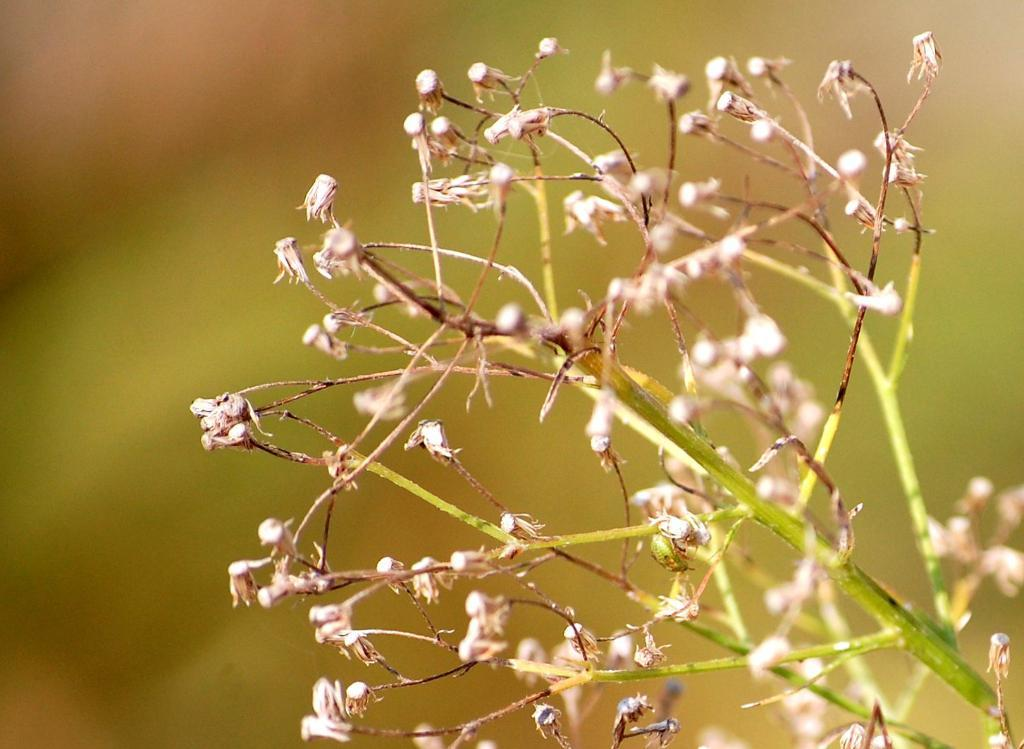Where was the image taken? The image was taken outdoors. Can you describe the background of the image? The background of the image is slightly blurred. What can be seen on the right side of the image? There is a plant on the right side of the image. What are the characteristics of the plant? The plant has stems and seeds. What type of kite is being flown in the image? There is no kite present in the image. How does the anger of the plant affect the image? Plants do not have emotions like anger, so this question is not applicable to the image. 